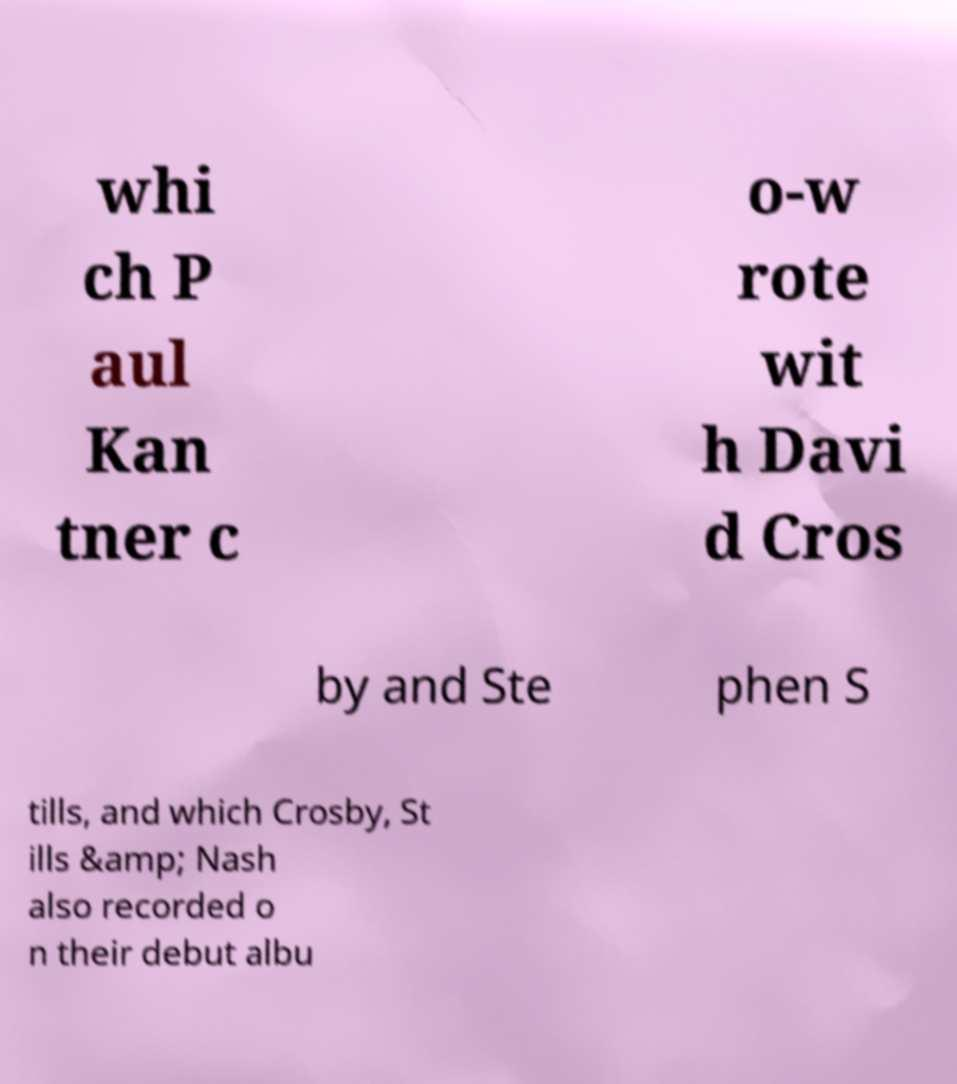Please read and relay the text visible in this image. What does it say? whi ch P aul Kan tner c o-w rote wit h Davi d Cros by and Ste phen S tills, and which Crosby, St ills &amp; Nash also recorded o n their debut albu 